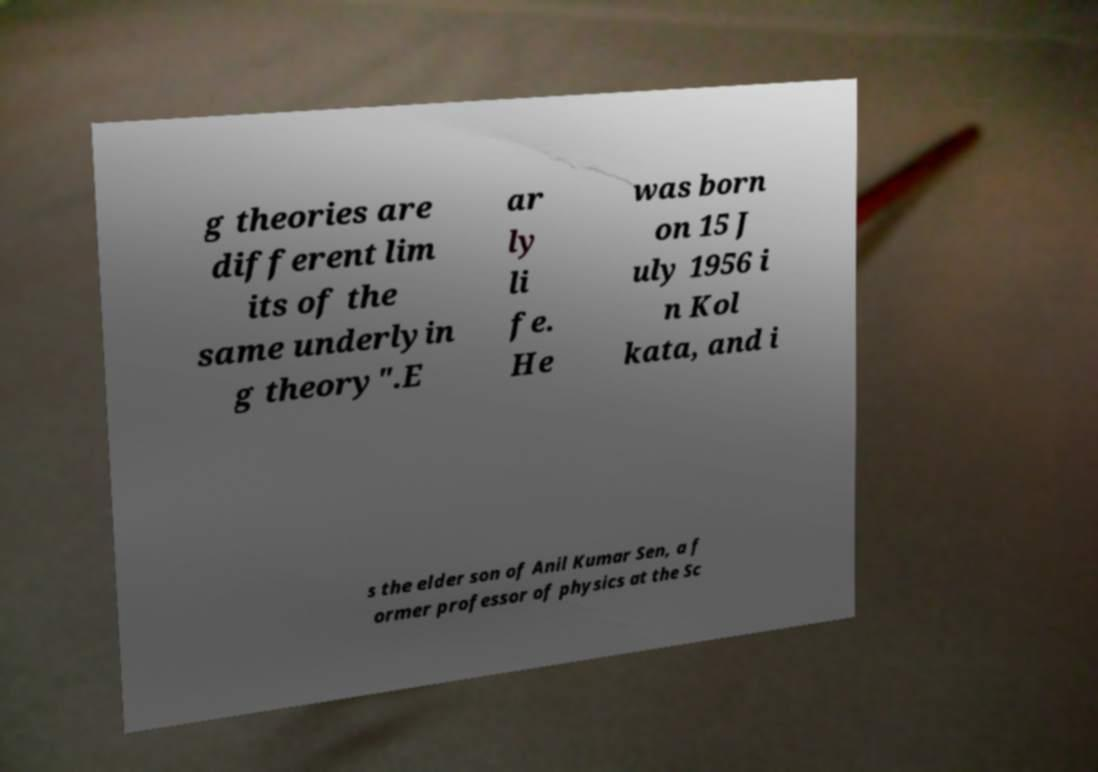What messages or text are displayed in this image? I need them in a readable, typed format. g theories are different lim its of the same underlyin g theory".E ar ly li fe. He was born on 15 J uly 1956 i n Kol kata, and i s the elder son of Anil Kumar Sen, a f ormer professor of physics at the Sc 